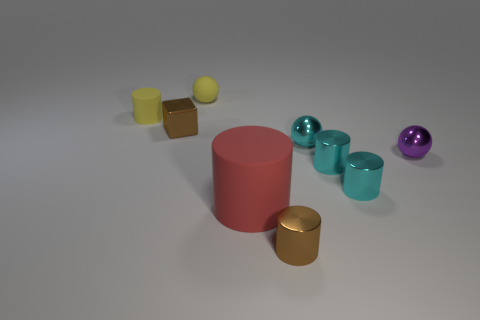There is a tiny matte object that is the same color as the tiny matte cylinder; what shape is it?
Offer a very short reply. Sphere. There is a object that is the same color as the small cube; what is its size?
Your response must be concise. Small. How many other things are the same size as the yellow matte cylinder?
Your answer should be very brief. 7. How many tiny things are purple balls or red things?
Ensure brevity in your answer.  1. There is a purple metallic thing; is it the same size as the rubber cylinder right of the small yellow matte cylinder?
Give a very brief answer. No. How many other objects are there of the same shape as the red object?
Make the answer very short. 4. There is a small purple thing that is the same material as the small cyan ball; what is its shape?
Ensure brevity in your answer.  Sphere. Are there any brown spheres?
Your response must be concise. No. Are there fewer small things that are behind the red matte cylinder than tiny purple things left of the matte ball?
Your response must be concise. No. There is a brown shiny thing that is to the left of the red rubber cylinder; what shape is it?
Offer a terse response. Cube. 